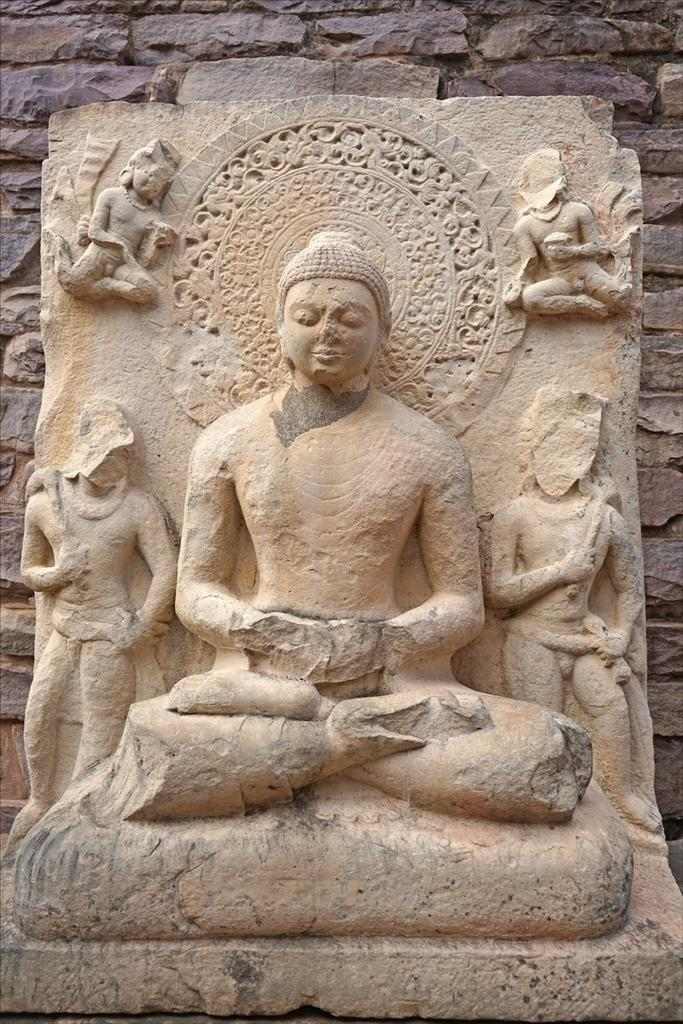What is the main subject in the center of the image? There is a sculpture in the center of the image. What can be seen in the background of the image? There is a wall in the background of the image. What type of dinner is being served in the image? There is no dinner present in the image; it features a sculpture and a wall. What idea is being expressed by the sculpture in the image? The image does not convey any specific idea or message; it simply shows a sculpture and a wall. 